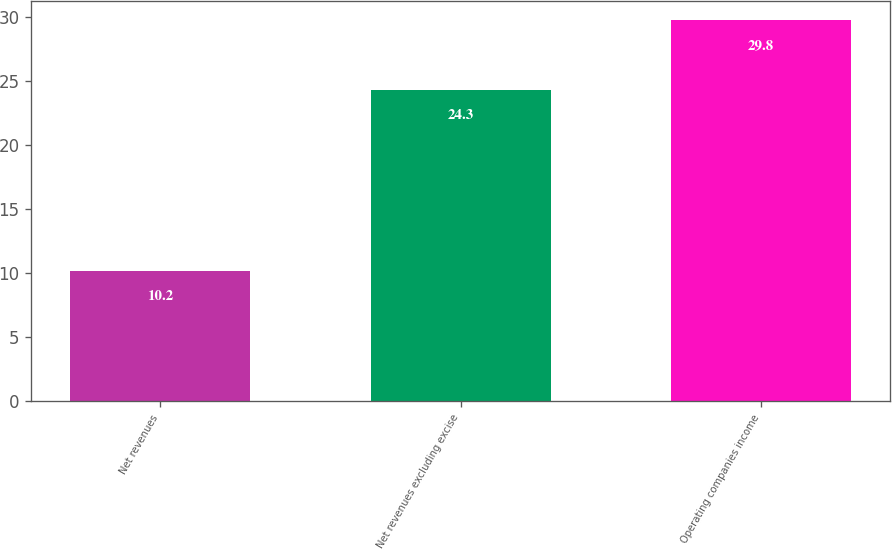Convert chart. <chart><loc_0><loc_0><loc_500><loc_500><bar_chart><fcel>Net revenues<fcel>Net revenues excluding excise<fcel>Operating companies income<nl><fcel>10.2<fcel>24.3<fcel>29.8<nl></chart> 